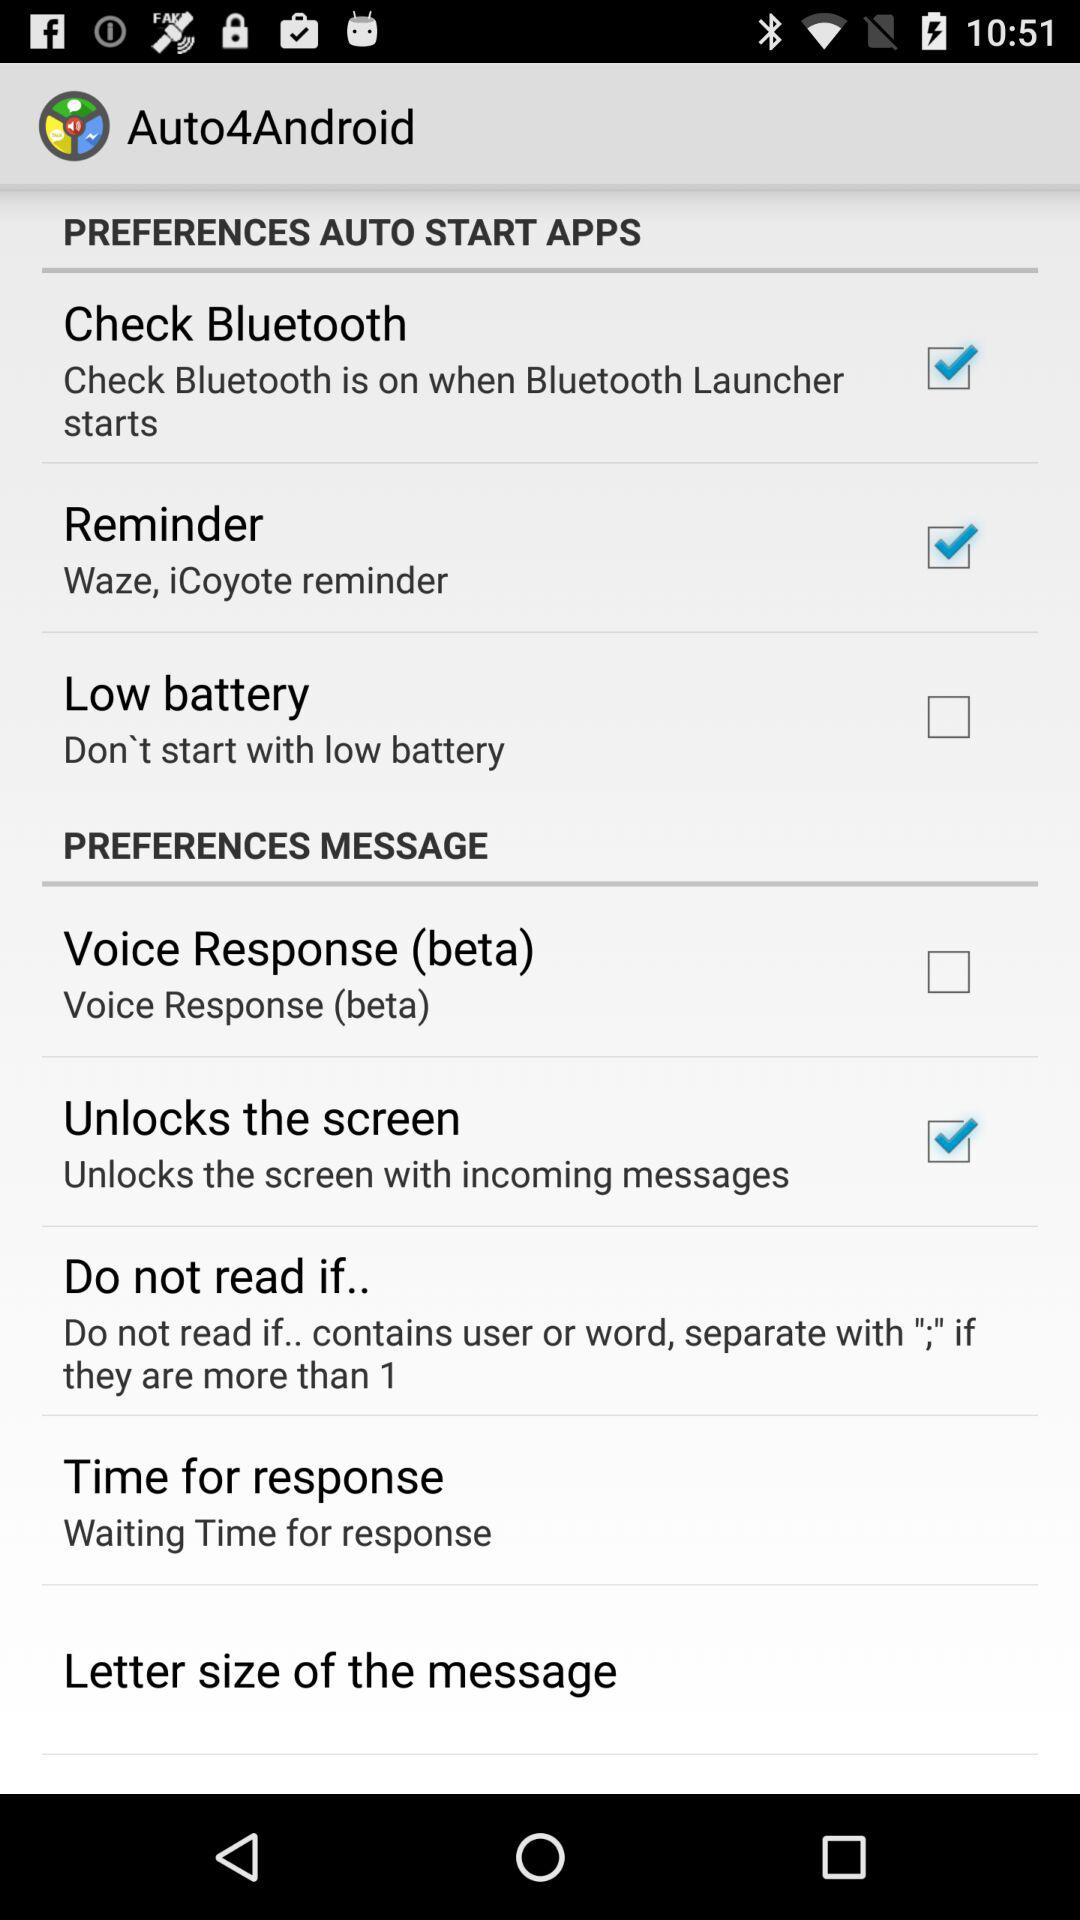How long is the wait time for a response?
When the provided information is insufficient, respond with <no answer>. <no answer> 